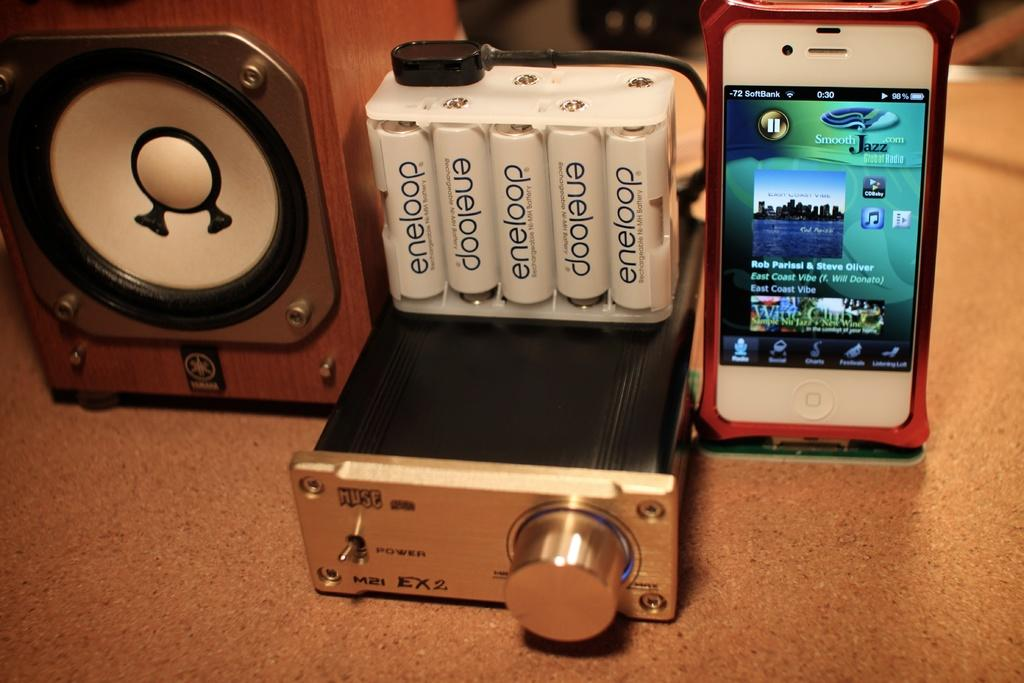<image>
Present a compact description of the photo's key features. a book that has eneloop written on it 